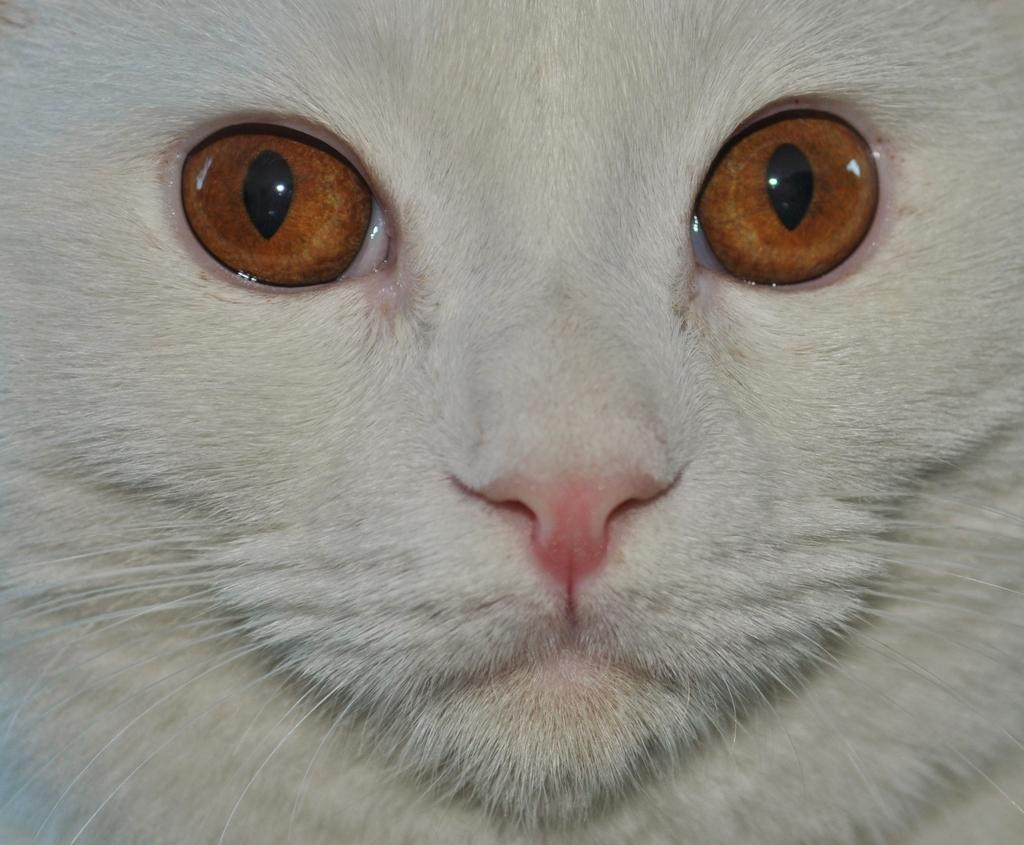What type of animal is in the image? There is a cat in the image. Can you describe the color of the cat? The cat is white in color. Where is the hat located in the image? There is no hat present in the image. What type of gate can be seen in the image? There is no gate present in the image. 